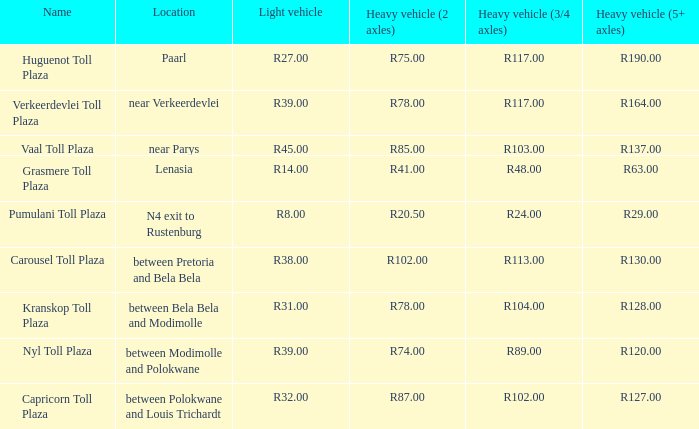Help me parse the entirety of this table. {'header': ['Name', 'Location', 'Light vehicle', 'Heavy vehicle (2 axles)', 'Heavy vehicle (3/4 axles)', 'Heavy vehicle (5+ axles)'], 'rows': [['Huguenot Toll Plaza', 'Paarl', 'R27.00', 'R75.00', 'R117.00', 'R190.00'], ['Verkeerdevlei Toll Plaza', 'near Verkeerdevlei', 'R39.00', 'R78.00', 'R117.00', 'R164.00'], ['Vaal Toll Plaza', 'near Parys', 'R45.00', 'R85.00', 'R103.00', 'R137.00'], ['Grasmere Toll Plaza', 'Lenasia', 'R14.00', 'R41.00', 'R48.00', 'R63.00'], ['Pumulani Toll Plaza', 'N4 exit to Rustenburg', 'R8.00', 'R20.50', 'R24.00', 'R29.00'], ['Carousel Toll Plaza', 'between Pretoria and Bela Bela', 'R38.00', 'R102.00', 'R113.00', 'R130.00'], ['Kranskop Toll Plaza', 'between Bela Bela and Modimolle', 'R31.00', 'R78.00', 'R104.00', 'R128.00'], ['Nyl Toll Plaza', 'between Modimolle and Polokwane', 'R39.00', 'R74.00', 'R89.00', 'R120.00'], ['Capricorn Toll Plaza', 'between Polokwane and Louis Trichardt', 'R32.00', 'R87.00', 'R102.00', 'R127.00']]} What plaza has a toll fee of r87.00 for heavy 2-axle vehicles? Capricorn Toll Plaza. 